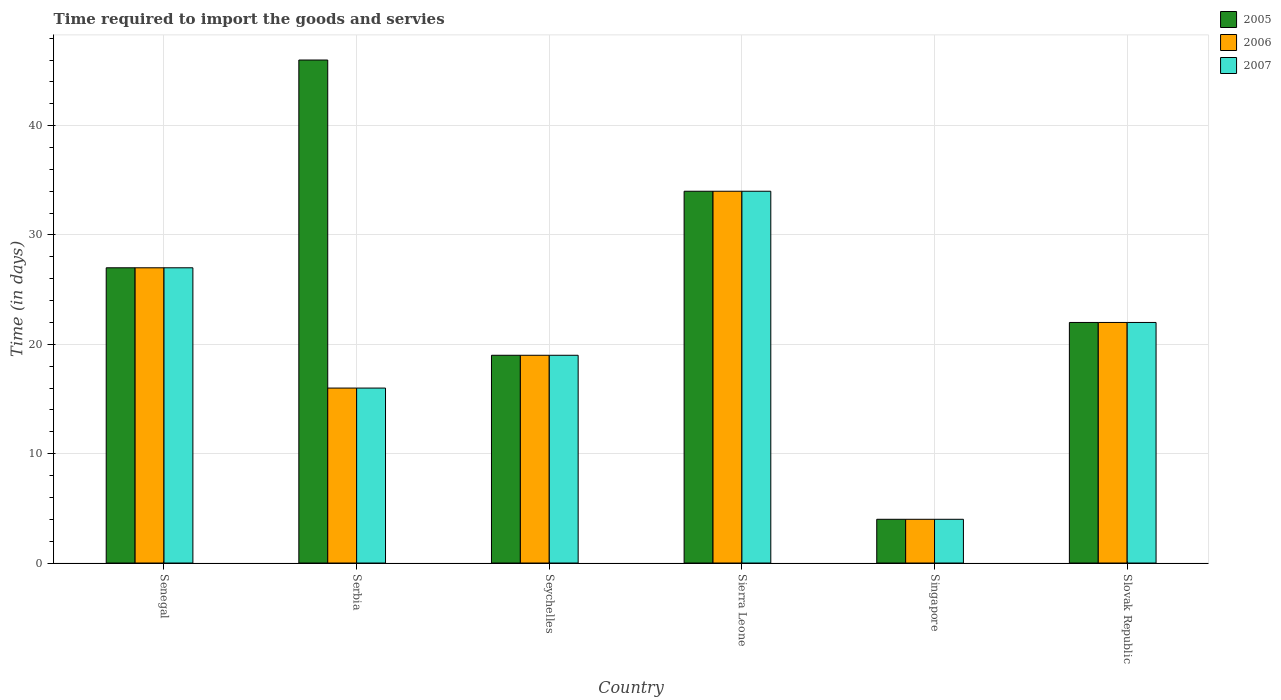Are the number of bars per tick equal to the number of legend labels?
Offer a terse response. Yes. Are the number of bars on each tick of the X-axis equal?
Offer a very short reply. Yes. How many bars are there on the 5th tick from the left?
Your answer should be compact. 3. What is the label of the 4th group of bars from the left?
Provide a succinct answer. Sierra Leone. In how many cases, is the number of bars for a given country not equal to the number of legend labels?
Provide a short and direct response. 0. In which country was the number of days required to import the goods and services in 2007 maximum?
Provide a short and direct response. Sierra Leone. In which country was the number of days required to import the goods and services in 2006 minimum?
Make the answer very short. Singapore. What is the total number of days required to import the goods and services in 2005 in the graph?
Provide a succinct answer. 152. What is the difference between the number of days required to import the goods and services in 2006 in Seychelles and the number of days required to import the goods and services in 2007 in Senegal?
Your response must be concise. -8. What is the average number of days required to import the goods and services in 2006 per country?
Your response must be concise. 20.33. In how many countries, is the number of days required to import the goods and services in 2007 greater than 12 days?
Make the answer very short. 5. What is the ratio of the number of days required to import the goods and services in 2005 in Sierra Leone to that in Slovak Republic?
Offer a very short reply. 1.55. Is the number of days required to import the goods and services in 2005 in Senegal less than that in Sierra Leone?
Your answer should be compact. Yes. What is the difference between the highest and the lowest number of days required to import the goods and services in 2007?
Make the answer very short. 30. In how many countries, is the number of days required to import the goods and services in 2007 greater than the average number of days required to import the goods and services in 2007 taken over all countries?
Offer a terse response. 3. What does the 1st bar from the right in Slovak Republic represents?
Offer a very short reply. 2007. Is it the case that in every country, the sum of the number of days required to import the goods and services in 2005 and number of days required to import the goods and services in 2006 is greater than the number of days required to import the goods and services in 2007?
Give a very brief answer. Yes. How many bars are there?
Offer a terse response. 18. How many countries are there in the graph?
Your response must be concise. 6. What is the difference between two consecutive major ticks on the Y-axis?
Your response must be concise. 10. Are the values on the major ticks of Y-axis written in scientific E-notation?
Your answer should be very brief. No. Does the graph contain any zero values?
Your answer should be very brief. No. Does the graph contain grids?
Make the answer very short. Yes. Where does the legend appear in the graph?
Provide a short and direct response. Top right. What is the title of the graph?
Your answer should be compact. Time required to import the goods and servies. Does "2005" appear as one of the legend labels in the graph?
Your response must be concise. Yes. What is the label or title of the Y-axis?
Offer a terse response. Time (in days). What is the Time (in days) in 2006 in Serbia?
Provide a succinct answer. 16. What is the Time (in days) of 2007 in Serbia?
Keep it short and to the point. 16. What is the Time (in days) in 2007 in Seychelles?
Offer a terse response. 19. What is the Time (in days) in 2005 in Sierra Leone?
Provide a short and direct response. 34. What is the Time (in days) in 2007 in Sierra Leone?
Offer a very short reply. 34. What is the Time (in days) in 2006 in Singapore?
Keep it short and to the point. 4. What is the Time (in days) in 2007 in Singapore?
Provide a succinct answer. 4. What is the Time (in days) in 2005 in Slovak Republic?
Make the answer very short. 22. What is the Time (in days) of 2007 in Slovak Republic?
Your answer should be very brief. 22. Across all countries, what is the maximum Time (in days) of 2006?
Your answer should be very brief. 34. Across all countries, what is the maximum Time (in days) of 2007?
Make the answer very short. 34. What is the total Time (in days) of 2005 in the graph?
Your response must be concise. 152. What is the total Time (in days) of 2006 in the graph?
Keep it short and to the point. 122. What is the total Time (in days) in 2007 in the graph?
Offer a very short reply. 122. What is the difference between the Time (in days) in 2005 in Senegal and that in Serbia?
Your response must be concise. -19. What is the difference between the Time (in days) of 2006 in Senegal and that in Serbia?
Your answer should be very brief. 11. What is the difference between the Time (in days) of 2006 in Senegal and that in Seychelles?
Offer a terse response. 8. What is the difference between the Time (in days) of 2006 in Senegal and that in Sierra Leone?
Your answer should be compact. -7. What is the difference between the Time (in days) of 2007 in Senegal and that in Sierra Leone?
Ensure brevity in your answer.  -7. What is the difference between the Time (in days) of 2005 in Senegal and that in Singapore?
Provide a succinct answer. 23. What is the difference between the Time (in days) in 2006 in Senegal and that in Singapore?
Your answer should be compact. 23. What is the difference between the Time (in days) of 2005 in Senegal and that in Slovak Republic?
Offer a terse response. 5. What is the difference between the Time (in days) in 2006 in Senegal and that in Slovak Republic?
Your answer should be very brief. 5. What is the difference between the Time (in days) of 2005 in Serbia and that in Seychelles?
Offer a very short reply. 27. What is the difference between the Time (in days) in 2006 in Serbia and that in Seychelles?
Your answer should be very brief. -3. What is the difference between the Time (in days) of 2007 in Serbia and that in Seychelles?
Make the answer very short. -3. What is the difference between the Time (in days) in 2005 in Serbia and that in Sierra Leone?
Make the answer very short. 12. What is the difference between the Time (in days) in 2007 in Serbia and that in Singapore?
Offer a very short reply. 12. What is the difference between the Time (in days) in 2005 in Serbia and that in Slovak Republic?
Give a very brief answer. 24. What is the difference between the Time (in days) in 2006 in Serbia and that in Slovak Republic?
Give a very brief answer. -6. What is the difference between the Time (in days) of 2007 in Serbia and that in Slovak Republic?
Provide a short and direct response. -6. What is the difference between the Time (in days) in 2005 in Seychelles and that in Sierra Leone?
Give a very brief answer. -15. What is the difference between the Time (in days) in 2007 in Seychelles and that in Sierra Leone?
Offer a very short reply. -15. What is the difference between the Time (in days) in 2006 in Seychelles and that in Singapore?
Provide a succinct answer. 15. What is the difference between the Time (in days) in 2006 in Seychelles and that in Slovak Republic?
Provide a succinct answer. -3. What is the difference between the Time (in days) of 2007 in Seychelles and that in Slovak Republic?
Provide a succinct answer. -3. What is the difference between the Time (in days) in 2007 in Sierra Leone and that in Slovak Republic?
Make the answer very short. 12. What is the difference between the Time (in days) in 2006 in Singapore and that in Slovak Republic?
Offer a terse response. -18. What is the difference between the Time (in days) of 2007 in Singapore and that in Slovak Republic?
Keep it short and to the point. -18. What is the difference between the Time (in days) of 2005 in Senegal and the Time (in days) of 2006 in Serbia?
Your answer should be compact. 11. What is the difference between the Time (in days) in 2005 in Senegal and the Time (in days) in 2006 in Seychelles?
Your answer should be compact. 8. What is the difference between the Time (in days) of 2005 in Senegal and the Time (in days) of 2006 in Sierra Leone?
Your answer should be compact. -7. What is the difference between the Time (in days) in 2006 in Senegal and the Time (in days) in 2007 in Sierra Leone?
Offer a very short reply. -7. What is the difference between the Time (in days) in 2006 in Senegal and the Time (in days) in 2007 in Singapore?
Your answer should be compact. 23. What is the difference between the Time (in days) in 2005 in Senegal and the Time (in days) in 2006 in Slovak Republic?
Keep it short and to the point. 5. What is the difference between the Time (in days) in 2005 in Senegal and the Time (in days) in 2007 in Slovak Republic?
Your answer should be very brief. 5. What is the difference between the Time (in days) in 2006 in Senegal and the Time (in days) in 2007 in Slovak Republic?
Your response must be concise. 5. What is the difference between the Time (in days) of 2006 in Serbia and the Time (in days) of 2007 in Seychelles?
Make the answer very short. -3. What is the difference between the Time (in days) of 2006 in Serbia and the Time (in days) of 2007 in Sierra Leone?
Your answer should be very brief. -18. What is the difference between the Time (in days) of 2005 in Serbia and the Time (in days) of 2007 in Singapore?
Make the answer very short. 42. What is the difference between the Time (in days) of 2006 in Serbia and the Time (in days) of 2007 in Singapore?
Give a very brief answer. 12. What is the difference between the Time (in days) of 2005 in Serbia and the Time (in days) of 2007 in Slovak Republic?
Offer a terse response. 24. What is the difference between the Time (in days) in 2005 in Seychelles and the Time (in days) in 2007 in Sierra Leone?
Your response must be concise. -15. What is the difference between the Time (in days) of 2006 in Seychelles and the Time (in days) of 2007 in Sierra Leone?
Keep it short and to the point. -15. What is the difference between the Time (in days) of 2005 in Seychelles and the Time (in days) of 2006 in Singapore?
Your answer should be very brief. 15. What is the difference between the Time (in days) in 2005 in Seychelles and the Time (in days) in 2007 in Singapore?
Provide a succinct answer. 15. What is the difference between the Time (in days) in 2006 in Seychelles and the Time (in days) in 2007 in Slovak Republic?
Keep it short and to the point. -3. What is the difference between the Time (in days) of 2005 in Sierra Leone and the Time (in days) of 2006 in Singapore?
Ensure brevity in your answer.  30. What is the difference between the Time (in days) in 2005 in Singapore and the Time (in days) in 2007 in Slovak Republic?
Offer a very short reply. -18. What is the difference between the Time (in days) of 2006 in Singapore and the Time (in days) of 2007 in Slovak Republic?
Your answer should be very brief. -18. What is the average Time (in days) in 2005 per country?
Your answer should be very brief. 25.33. What is the average Time (in days) of 2006 per country?
Ensure brevity in your answer.  20.33. What is the average Time (in days) in 2007 per country?
Offer a very short reply. 20.33. What is the difference between the Time (in days) of 2005 and Time (in days) of 2006 in Senegal?
Give a very brief answer. 0. What is the difference between the Time (in days) in 2006 and Time (in days) in 2007 in Senegal?
Provide a succinct answer. 0. What is the difference between the Time (in days) of 2005 and Time (in days) of 2007 in Serbia?
Offer a terse response. 30. What is the difference between the Time (in days) of 2005 and Time (in days) of 2007 in Seychelles?
Your response must be concise. 0. What is the difference between the Time (in days) of 2006 and Time (in days) of 2007 in Seychelles?
Offer a very short reply. 0. What is the difference between the Time (in days) of 2005 and Time (in days) of 2006 in Sierra Leone?
Keep it short and to the point. 0. What is the difference between the Time (in days) in 2005 and Time (in days) in 2007 in Sierra Leone?
Your answer should be compact. 0. What is the difference between the Time (in days) in 2005 and Time (in days) in 2006 in Singapore?
Offer a terse response. 0. What is the difference between the Time (in days) of 2005 and Time (in days) of 2006 in Slovak Republic?
Provide a succinct answer. 0. What is the difference between the Time (in days) in 2005 and Time (in days) in 2007 in Slovak Republic?
Ensure brevity in your answer.  0. What is the ratio of the Time (in days) of 2005 in Senegal to that in Serbia?
Keep it short and to the point. 0.59. What is the ratio of the Time (in days) of 2006 in Senegal to that in Serbia?
Make the answer very short. 1.69. What is the ratio of the Time (in days) of 2007 in Senegal to that in Serbia?
Offer a terse response. 1.69. What is the ratio of the Time (in days) of 2005 in Senegal to that in Seychelles?
Keep it short and to the point. 1.42. What is the ratio of the Time (in days) in 2006 in Senegal to that in Seychelles?
Ensure brevity in your answer.  1.42. What is the ratio of the Time (in days) in 2007 in Senegal to that in Seychelles?
Make the answer very short. 1.42. What is the ratio of the Time (in days) of 2005 in Senegal to that in Sierra Leone?
Offer a terse response. 0.79. What is the ratio of the Time (in days) in 2006 in Senegal to that in Sierra Leone?
Offer a terse response. 0.79. What is the ratio of the Time (in days) of 2007 in Senegal to that in Sierra Leone?
Offer a terse response. 0.79. What is the ratio of the Time (in days) in 2005 in Senegal to that in Singapore?
Ensure brevity in your answer.  6.75. What is the ratio of the Time (in days) in 2006 in Senegal to that in Singapore?
Your response must be concise. 6.75. What is the ratio of the Time (in days) in 2007 in Senegal to that in Singapore?
Your answer should be compact. 6.75. What is the ratio of the Time (in days) in 2005 in Senegal to that in Slovak Republic?
Ensure brevity in your answer.  1.23. What is the ratio of the Time (in days) in 2006 in Senegal to that in Slovak Republic?
Offer a very short reply. 1.23. What is the ratio of the Time (in days) in 2007 in Senegal to that in Slovak Republic?
Your answer should be very brief. 1.23. What is the ratio of the Time (in days) in 2005 in Serbia to that in Seychelles?
Ensure brevity in your answer.  2.42. What is the ratio of the Time (in days) in 2006 in Serbia to that in Seychelles?
Offer a terse response. 0.84. What is the ratio of the Time (in days) in 2007 in Serbia to that in Seychelles?
Provide a succinct answer. 0.84. What is the ratio of the Time (in days) in 2005 in Serbia to that in Sierra Leone?
Give a very brief answer. 1.35. What is the ratio of the Time (in days) of 2006 in Serbia to that in Sierra Leone?
Offer a very short reply. 0.47. What is the ratio of the Time (in days) in 2007 in Serbia to that in Sierra Leone?
Offer a very short reply. 0.47. What is the ratio of the Time (in days) of 2005 in Serbia to that in Singapore?
Offer a very short reply. 11.5. What is the ratio of the Time (in days) of 2007 in Serbia to that in Singapore?
Provide a short and direct response. 4. What is the ratio of the Time (in days) in 2005 in Serbia to that in Slovak Republic?
Your answer should be very brief. 2.09. What is the ratio of the Time (in days) in 2006 in Serbia to that in Slovak Republic?
Keep it short and to the point. 0.73. What is the ratio of the Time (in days) in 2007 in Serbia to that in Slovak Republic?
Give a very brief answer. 0.73. What is the ratio of the Time (in days) in 2005 in Seychelles to that in Sierra Leone?
Ensure brevity in your answer.  0.56. What is the ratio of the Time (in days) of 2006 in Seychelles to that in Sierra Leone?
Keep it short and to the point. 0.56. What is the ratio of the Time (in days) in 2007 in Seychelles to that in Sierra Leone?
Offer a very short reply. 0.56. What is the ratio of the Time (in days) of 2005 in Seychelles to that in Singapore?
Your response must be concise. 4.75. What is the ratio of the Time (in days) in 2006 in Seychelles to that in Singapore?
Offer a very short reply. 4.75. What is the ratio of the Time (in days) in 2007 in Seychelles to that in Singapore?
Keep it short and to the point. 4.75. What is the ratio of the Time (in days) in 2005 in Seychelles to that in Slovak Republic?
Your response must be concise. 0.86. What is the ratio of the Time (in days) of 2006 in Seychelles to that in Slovak Republic?
Give a very brief answer. 0.86. What is the ratio of the Time (in days) in 2007 in Seychelles to that in Slovak Republic?
Provide a succinct answer. 0.86. What is the ratio of the Time (in days) in 2005 in Sierra Leone to that in Singapore?
Give a very brief answer. 8.5. What is the ratio of the Time (in days) of 2007 in Sierra Leone to that in Singapore?
Your response must be concise. 8.5. What is the ratio of the Time (in days) in 2005 in Sierra Leone to that in Slovak Republic?
Offer a terse response. 1.55. What is the ratio of the Time (in days) of 2006 in Sierra Leone to that in Slovak Republic?
Your answer should be compact. 1.55. What is the ratio of the Time (in days) in 2007 in Sierra Leone to that in Slovak Republic?
Offer a terse response. 1.55. What is the ratio of the Time (in days) of 2005 in Singapore to that in Slovak Republic?
Your response must be concise. 0.18. What is the ratio of the Time (in days) in 2006 in Singapore to that in Slovak Republic?
Make the answer very short. 0.18. What is the ratio of the Time (in days) of 2007 in Singapore to that in Slovak Republic?
Give a very brief answer. 0.18. What is the difference between the highest and the second highest Time (in days) of 2006?
Your response must be concise. 7. What is the difference between the highest and the lowest Time (in days) in 2007?
Your answer should be compact. 30. 